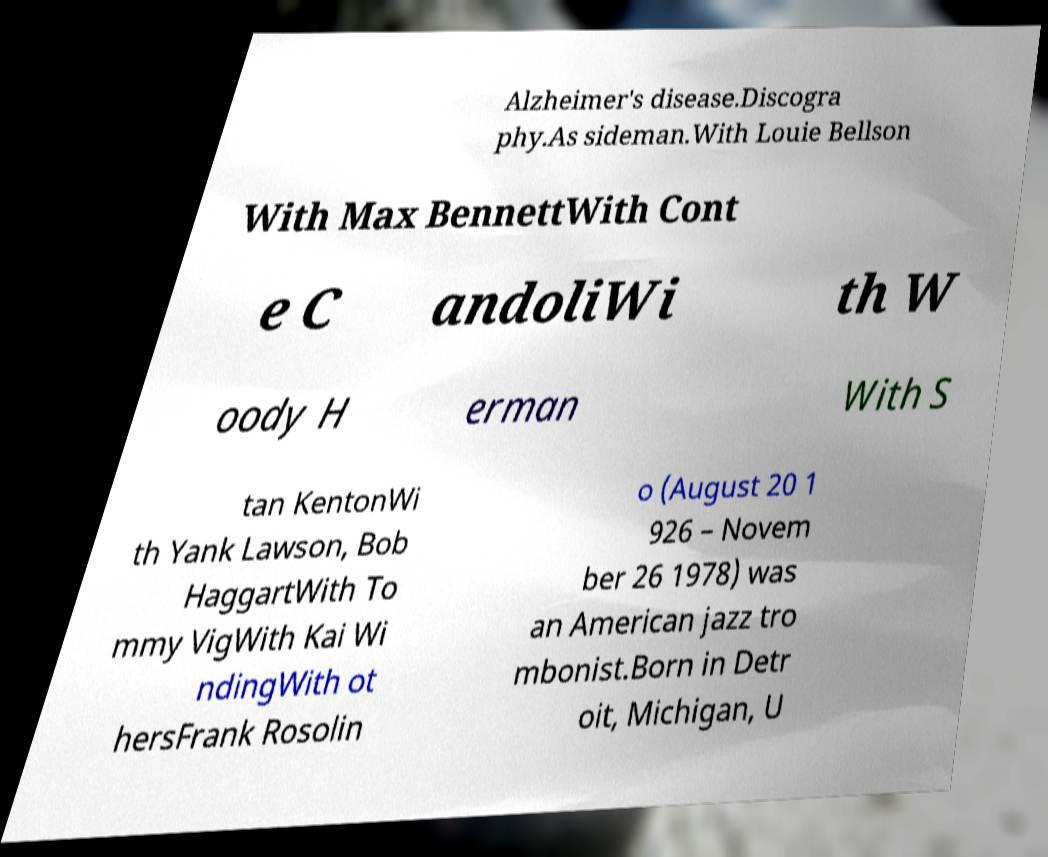Could you extract and type out the text from this image? Alzheimer's disease.Discogra phy.As sideman.With Louie Bellson With Max BennettWith Cont e C andoliWi th W oody H erman With S tan KentonWi th Yank Lawson, Bob HaggartWith To mmy VigWith Kai Wi ndingWith ot hersFrank Rosolin o (August 20 1 926 – Novem ber 26 1978) was an American jazz tro mbonist.Born in Detr oit, Michigan, U 